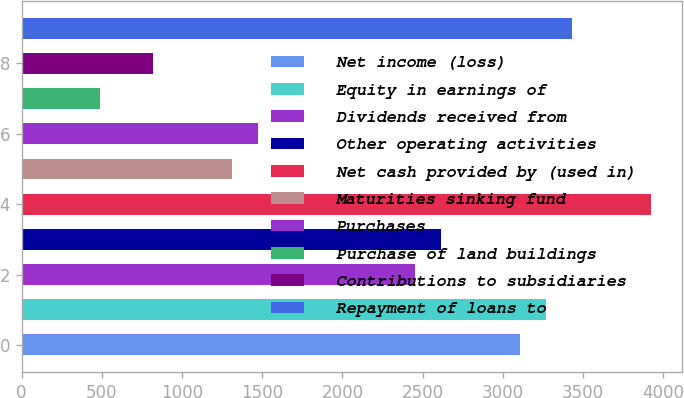<chart> <loc_0><loc_0><loc_500><loc_500><bar_chart><fcel>Net income (loss)<fcel>Equity in earnings of<fcel>Dividends received from<fcel>Other operating activities<fcel>Net cash provided by (used in)<fcel>Maturities sinking fund<fcel>Purchases<fcel>Purchase of land buildings<fcel>Contributions to subsidiaries<fcel>Repayment of loans to<nl><fcel>3106.6<fcel>3270<fcel>2453<fcel>2616.4<fcel>3923.6<fcel>1309.2<fcel>1472.6<fcel>492.2<fcel>819<fcel>3433.4<nl></chart> 